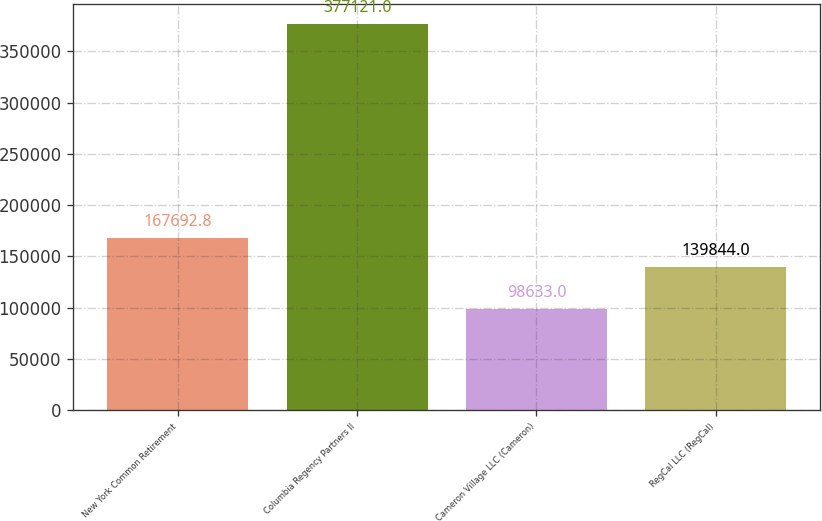Convert chart. <chart><loc_0><loc_0><loc_500><loc_500><bar_chart><fcel>New York Common Retirement<fcel>Columbia Regency Partners II<fcel>Cameron Village LLC (Cameron)<fcel>RegCal LLC (RegCal)<nl><fcel>167693<fcel>377121<fcel>98633<fcel>139844<nl></chart> 